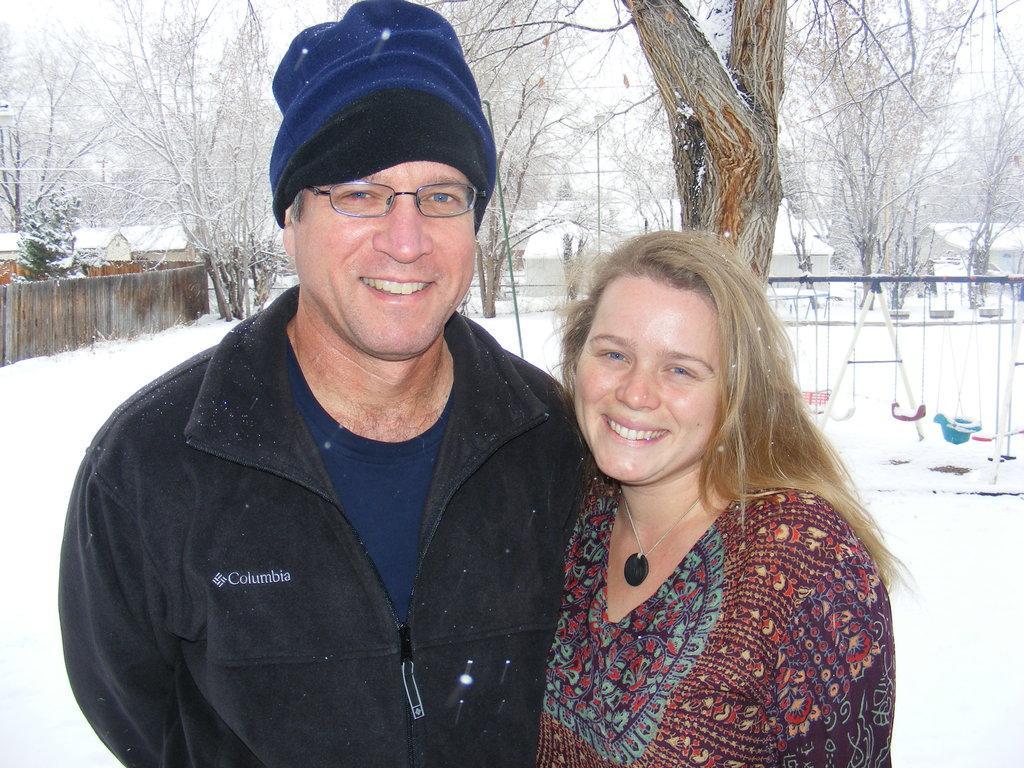Can you describe this image briefly? In this image I can see a man and a woman. In the background, I can see the snow and the trees. 